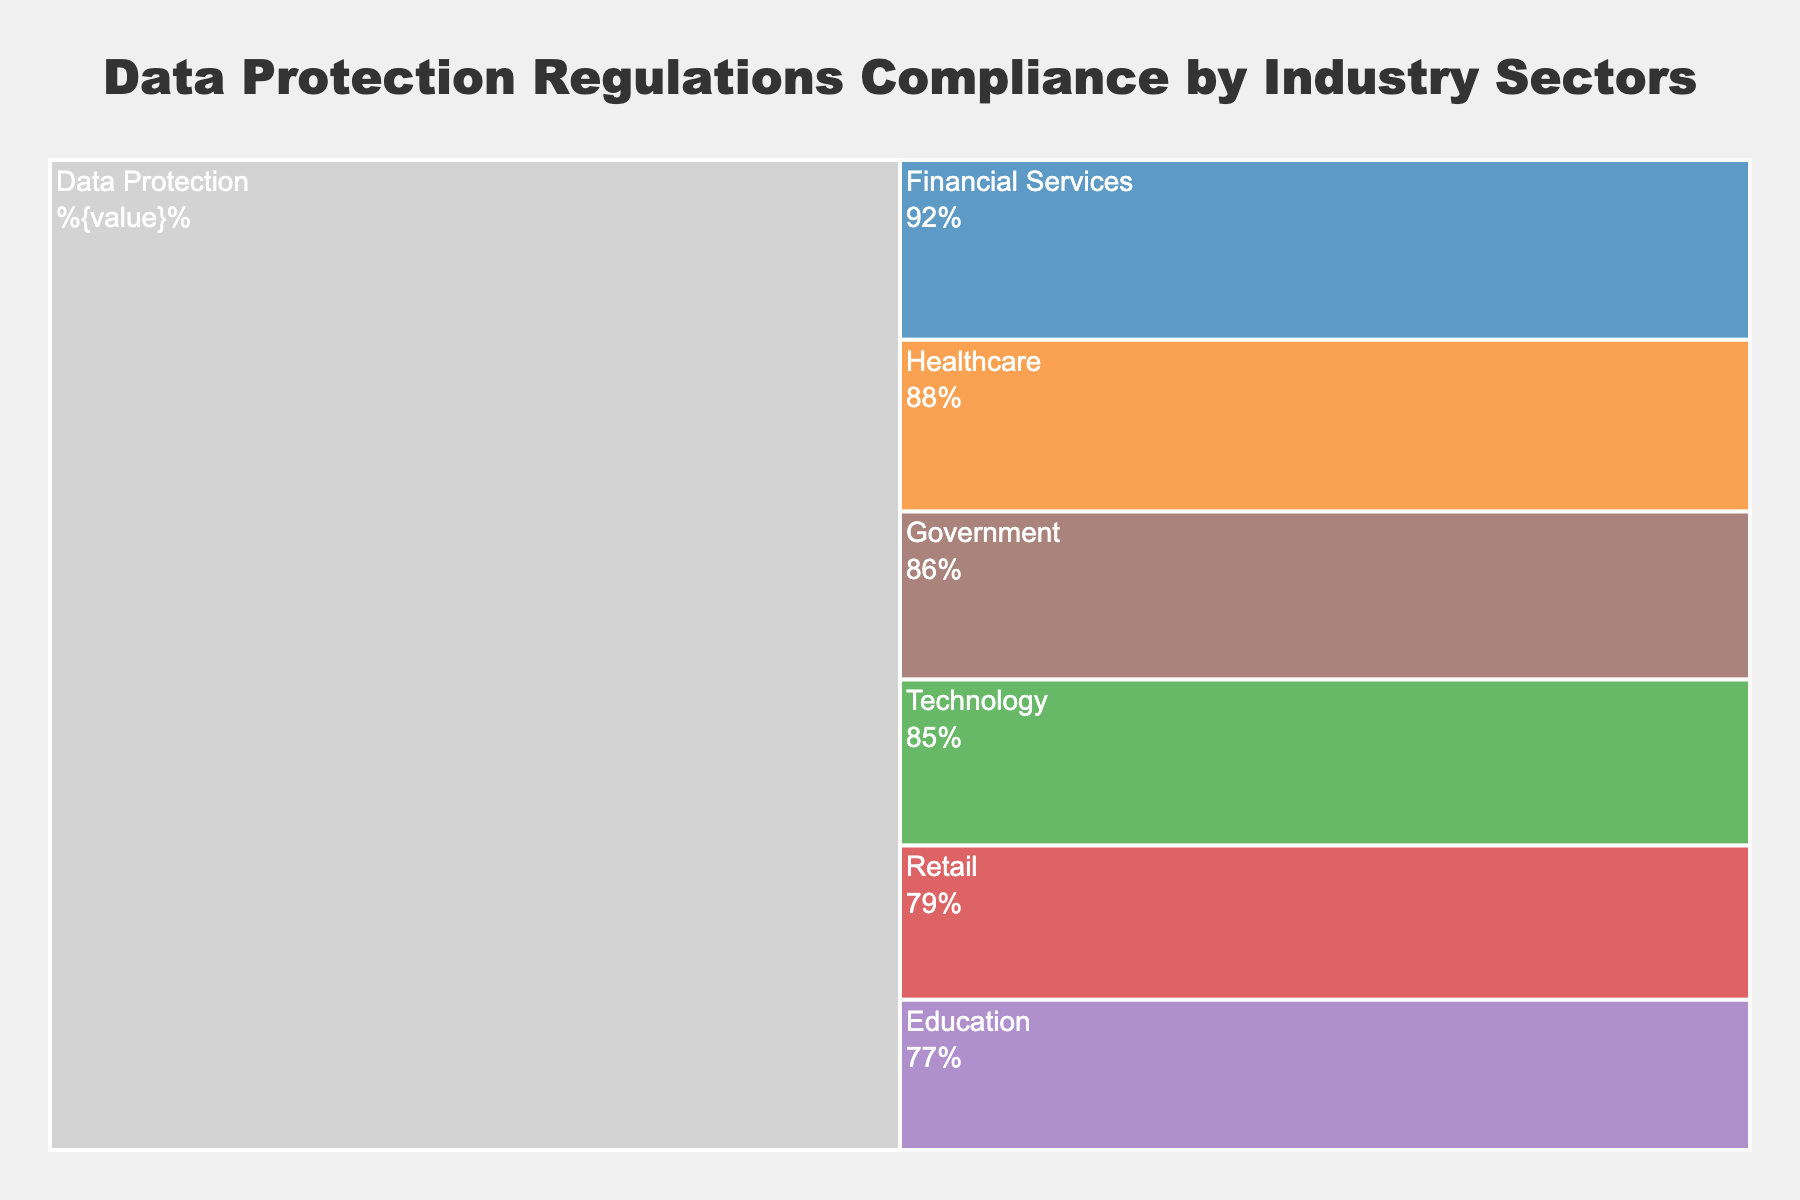Which industry sector has the highest compliance rate? The figure shows various industry sectors with their corresponding compliance rates. The Financial Services sector has the highest rate at 92%.
Answer: Financial Services Which industry sector has the lowest compliance rate? The figure displays compliance rates for each sector. The Retail sector has the lowest compliance rate, which is 79%.
Answer: Retail What is the overall theme of the chart? The chart's title reads 'Data Protection Regulations Compliance by Industry Sectors,' indicating the comparison of compliance rates across different sectors regarding data protection regulations.
Answer: Data Protection Regulations Compliance by Industry Sectors How many industry sectors are displayed in the chart? The chart displays six different industry sectors. Each branch represents a distinct sector.
Answer: Six What is the average compliance rate across all industry sectors? Add up all the compliance rates (92 + 88 + 85 + 79 + 77 + 86) to get 507. Divide this sum by the number of sectors, which is 6. The average compliance rate is 507/6 ≈ 84.5%.
Answer: 84.5% By how much does the compliance rate in the Financial Services sector exceed the rate in the Retail sector? The compliance rate for Financial Services is 92%, and for Retail, it is 79%. Subtract the lower rate from the higher rate: 92 - 79 = 13%.
Answer: 13% Which two sectors have the closest compliance rates, and what is the difference between them? Comparing the compliance rates, Healthcare (88%) and Government (86%) are the closest. The difference between these two is 88 - 86 = 2%.
Answer: Healthcare and Government, 2% How is the visual representation of the different compliance rates distinguished in the chart? The sectors are represented by branches extending from the root (Data Protection). Different colors are used to distinguish between each sector, and each branch's width represents the compliance rate.
Answer: Branches with different colors and widths What color is used to represent the Technology sector in the chart? The Technology sector is denoted by the third branch and is colored using a medium green hue.
Answer: Green Which sector ranks third in compliance rate, and what is its value? The Technology sector ranks third with a compliance rate of 85%, following Financial Services (92%) and Healthcare (88%).
Answer: Technology, 85% 